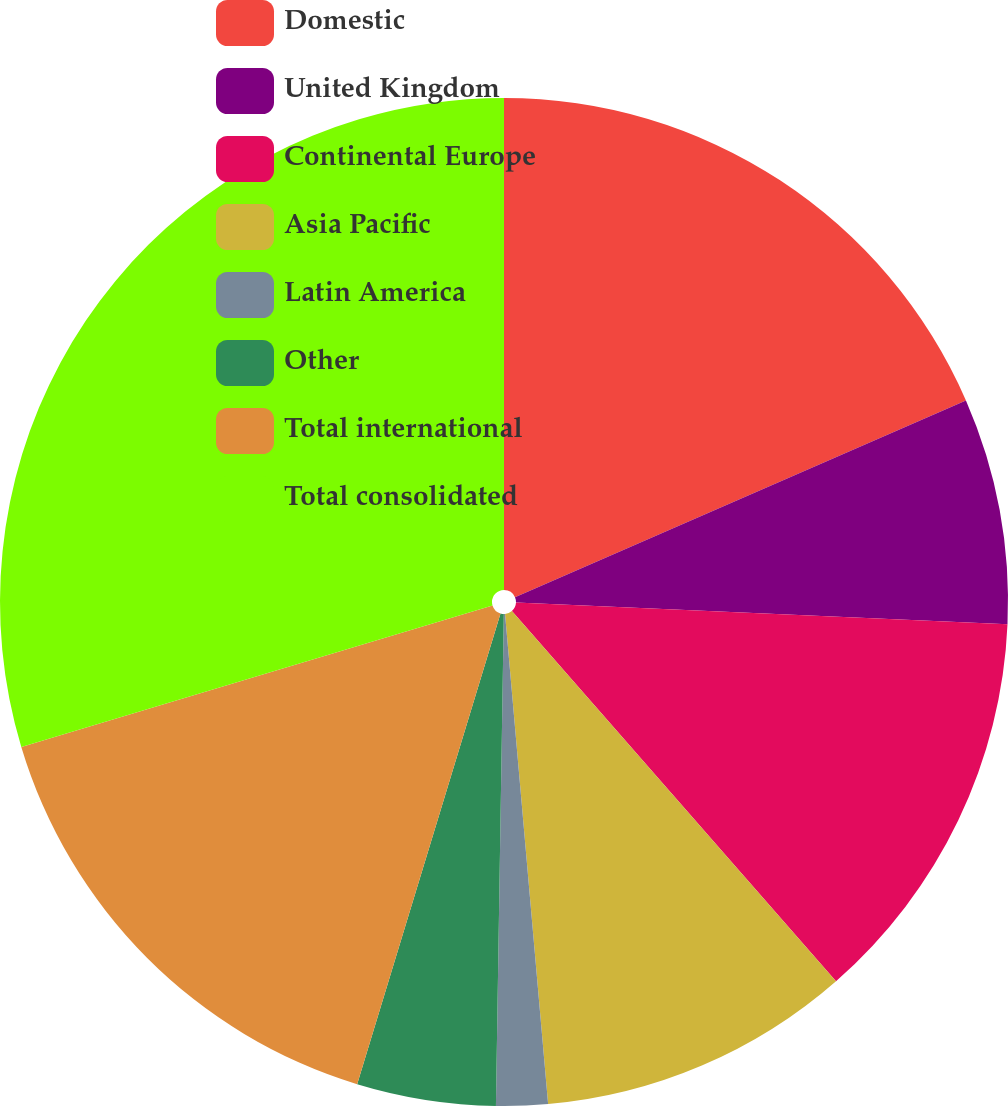Convert chart to OTSL. <chart><loc_0><loc_0><loc_500><loc_500><pie_chart><fcel>Domestic<fcel>United Kingdom<fcel>Continental Europe<fcel>Asia Pacific<fcel>Latin America<fcel>Other<fcel>Total international<fcel>Total consolidated<nl><fcel>18.45%<fcel>7.25%<fcel>12.85%<fcel>10.05%<fcel>1.65%<fcel>4.45%<fcel>15.65%<fcel>29.64%<nl></chart> 